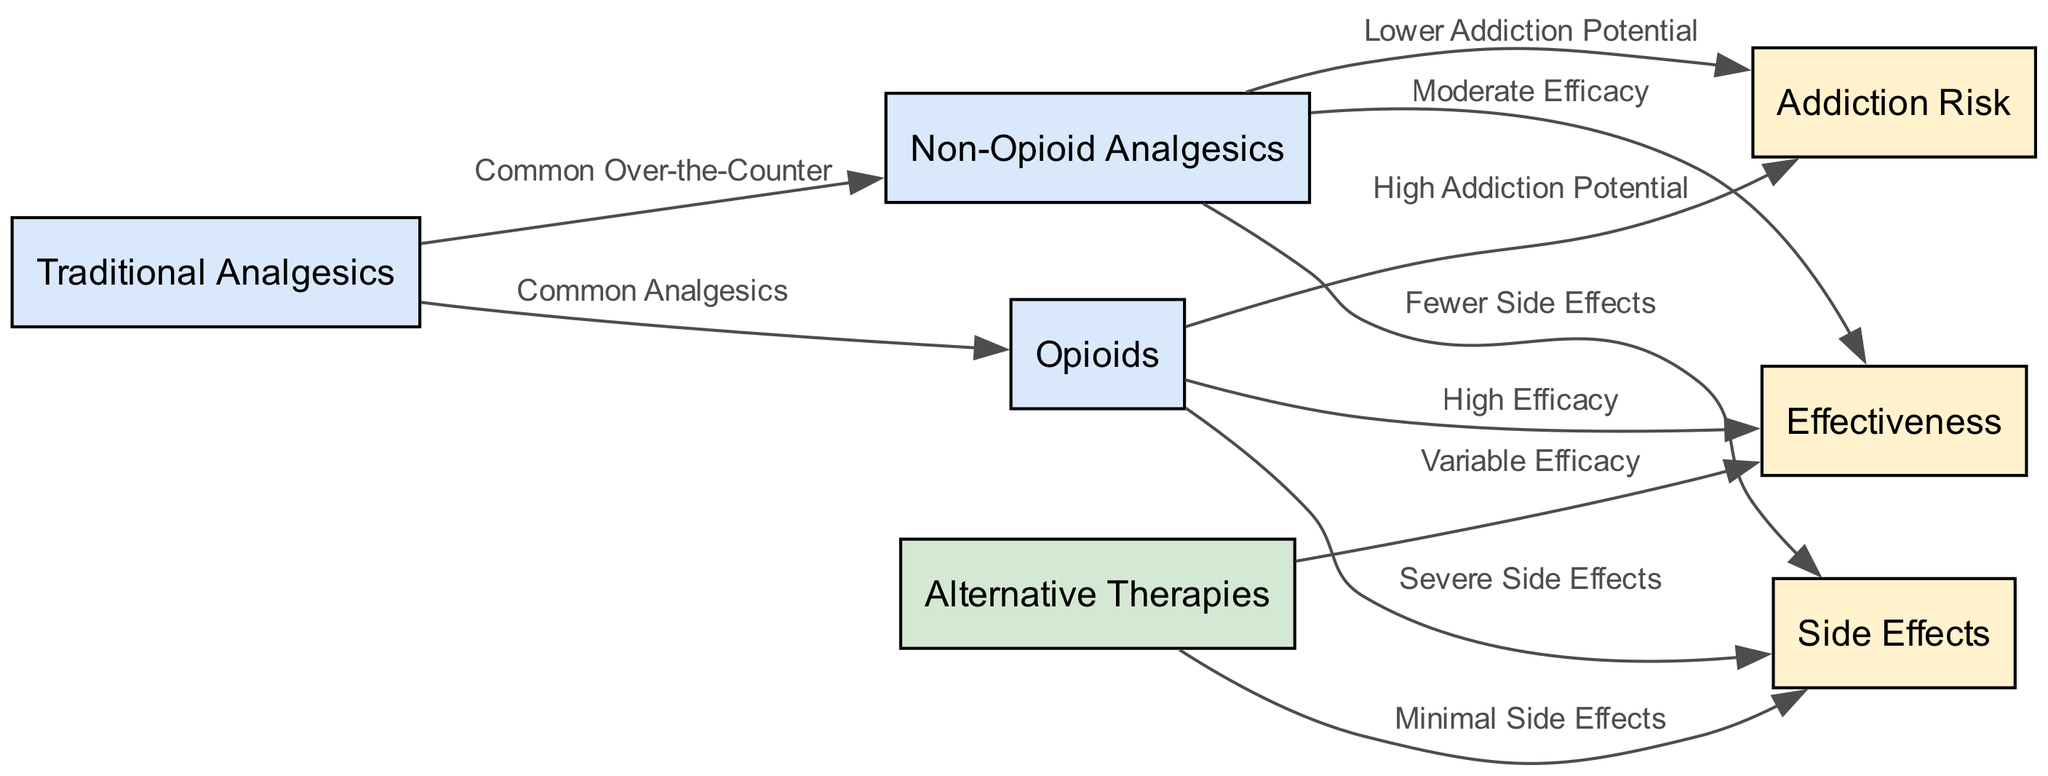What is the node representing non-opioid analgesics? The node representing non-opioid analgesics is labeled "Non-Opioid Analgesics". It is one of the main pain management methods depicted in the diagram.
Answer: Non-Opioid Analgesics How many edges are connected to the node for opioids? The node for opioids is connected to three edges, which indicate relationships with addiction risk, effectiveness, and side effects, demonstrating the various aspects of opioids in pain management.
Answer: 3 What type of pain management method has the highest efficacy? The node for opioids indicates "High Efficacy" for very effective severe pain relief. This shows that among the listed methods, opioids are identified as the top method for effectiveness in pain management.
Answer: Opioids Which pain management method is associated with minimal side effects? The node for alternative therapies is linked to "Minimal Side Effects," indicating that this method typically results in fewer negative health consequences as compared to the others.
Answer: Alternative Therapies What describes the addiction risk associated with non-opioid analgesics? The diagram shows that non-opioid analgesics have a connection labeled "Lower Addiction Potential," indicating they present a reduced risk of dependency relative to other pain management methods.
Answer: Lower Addiction Potential What node connects traditional analgesics and non-opioid analgesics? The diagram indicates a connection between traditional analgesics and non-opioid analgesics labeled "Common Over-the-Counter," linking them as both available options for pain relief.
Answer: Common Over-the-Counter What describes the side effects of opioids based on this diagram? According to the diagram, opioids have "Severe Side Effects," which includes serious health issues such as respiratory depression and constipation. This highlights the potential dangers of using opioids for pain management.
Answer: Severe Side Effects Which pain management method depends on individual therapy and shows variable efficacy? The node for alternative therapies is linked to "Variable Efficacy," indicating that the effectiveness of this method can vary greatly from person to person and based on the specific therapeutic approach used.
Answer: Alternative Therapies What is the primary feature of traditional analgesics mentioned in the diagram? The diagram describes traditional analgesics through the edge labeled "Common Analgesics," showing that they include both standard and medically utilized pain relief medications derived from various substances.
Answer: Common Analgesics 